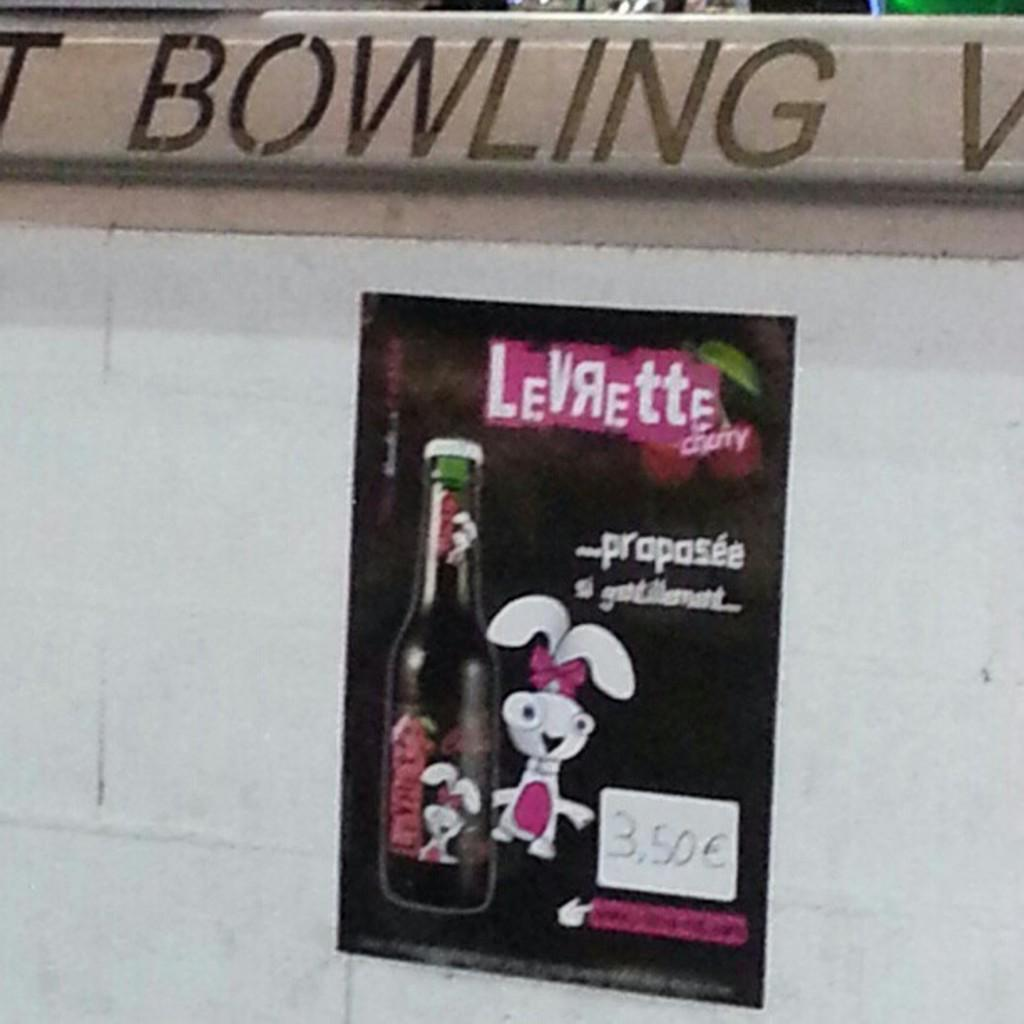<image>
Relay a brief, clear account of the picture shown. An ad add for a drink called Levrette with a drawing of a rabbit. 